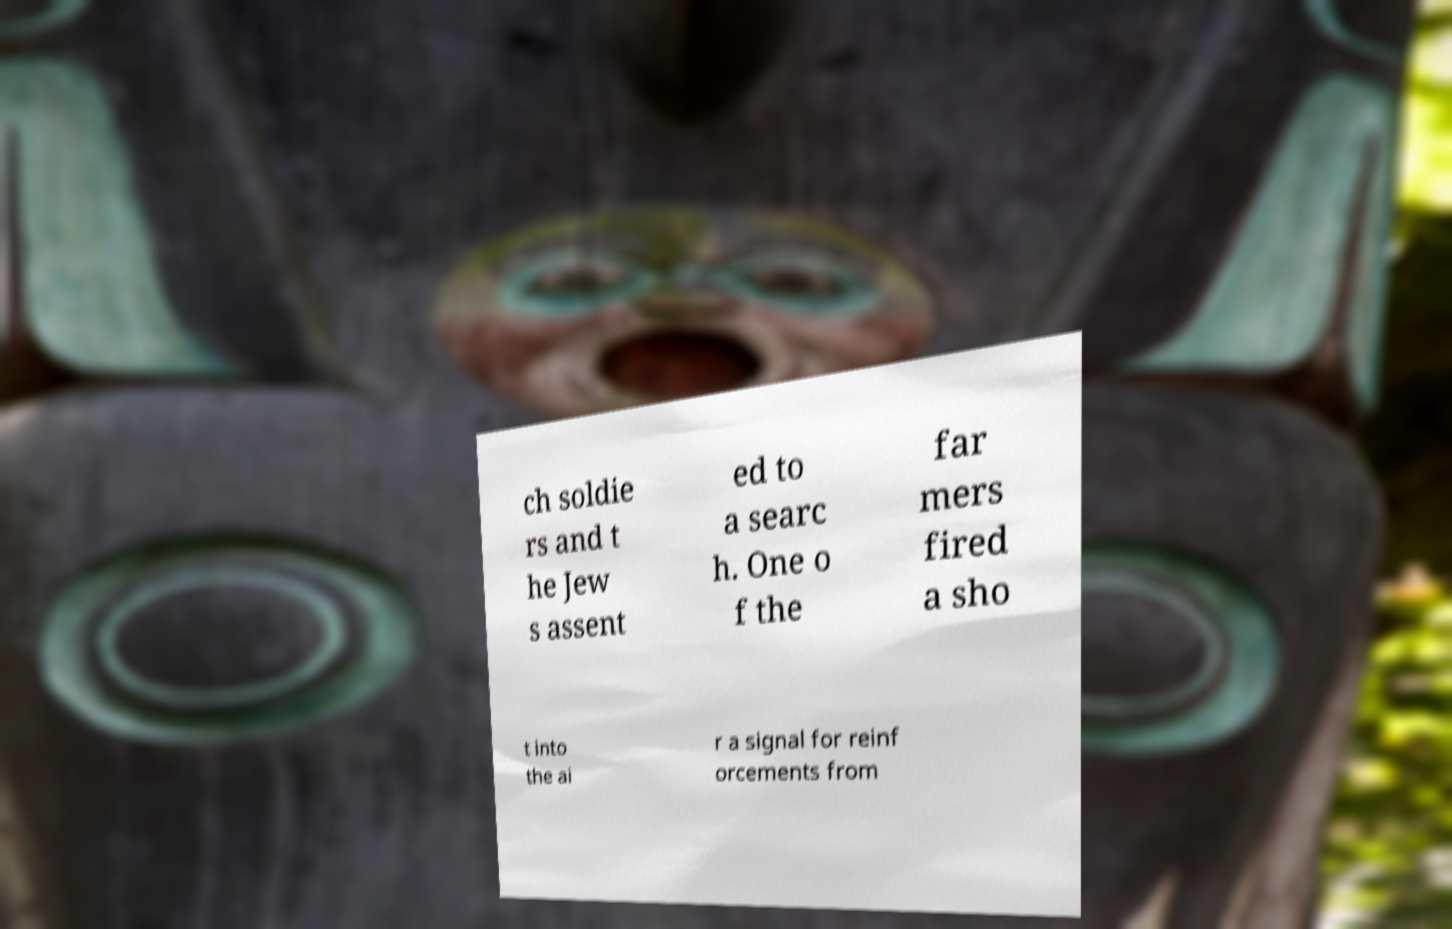Could you extract and type out the text from this image? ch soldie rs and t he Jew s assent ed to a searc h. One o f the far mers fired a sho t into the ai r a signal for reinf orcements from 